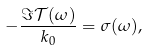<formula> <loc_0><loc_0><loc_500><loc_500>- \frac { \Im \mathcal { T } ( \omega ) } { k _ { 0 } } = \sigma ( \omega ) ,</formula> 